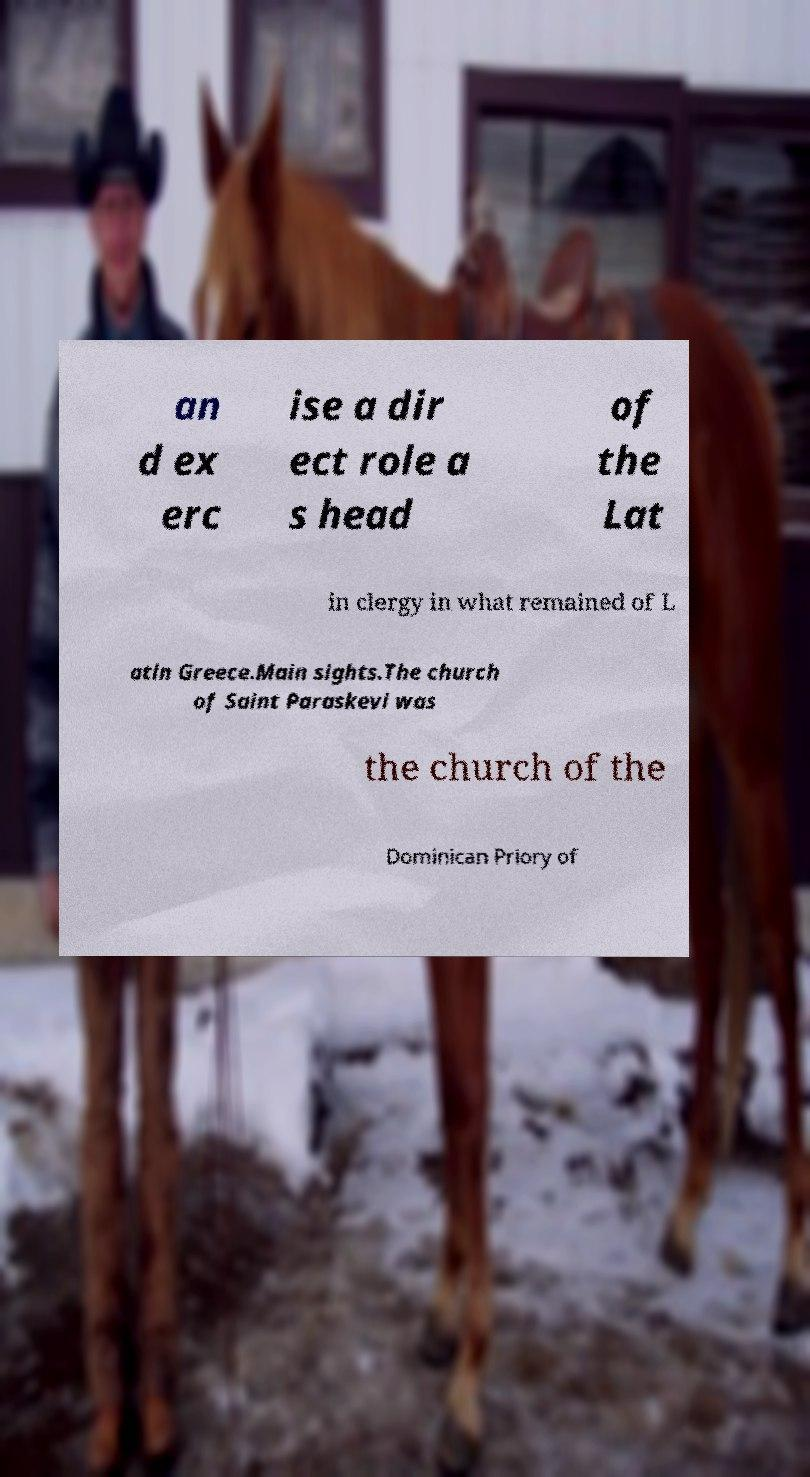Can you read and provide the text displayed in the image?This photo seems to have some interesting text. Can you extract and type it out for me? an d ex erc ise a dir ect role a s head of the Lat in clergy in what remained of L atin Greece.Main sights.The church of Saint Paraskevi was the church of the Dominican Priory of 